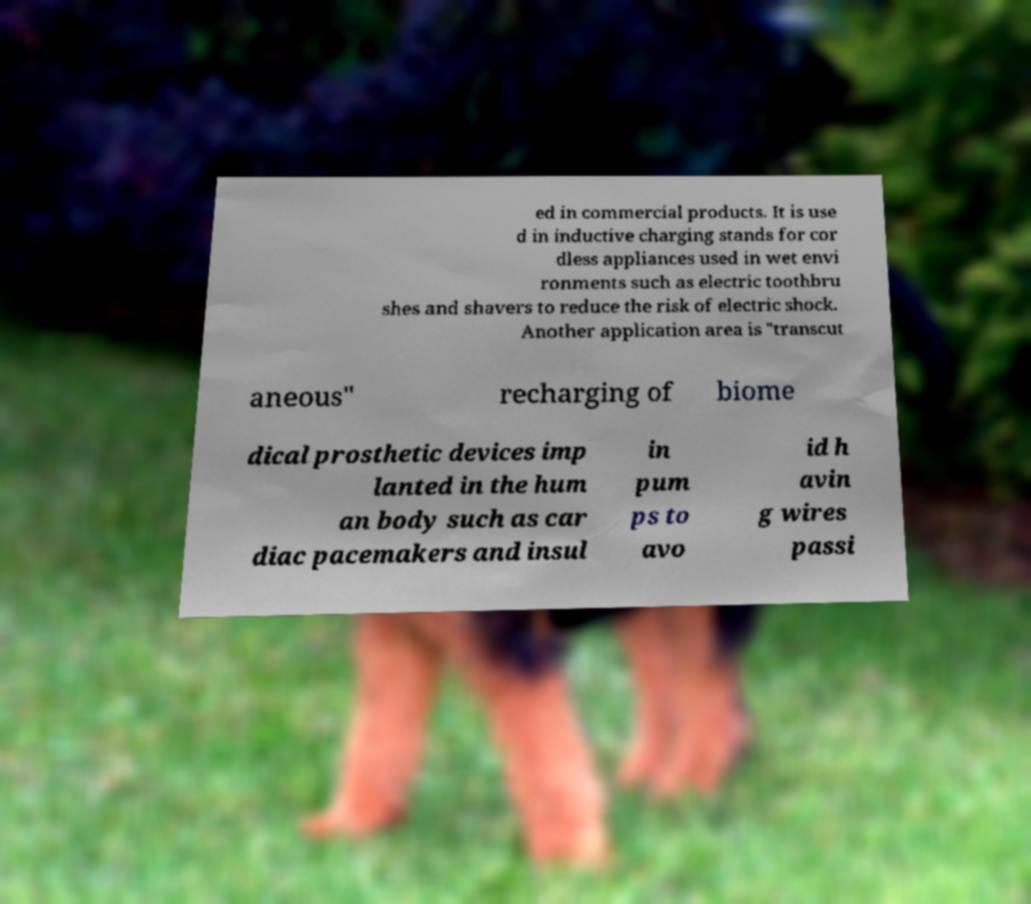For documentation purposes, I need the text within this image transcribed. Could you provide that? ed in commercial products. It is use d in inductive charging stands for cor dless appliances used in wet envi ronments such as electric toothbru shes and shavers to reduce the risk of electric shock. Another application area is "transcut aneous" recharging of biome dical prosthetic devices imp lanted in the hum an body such as car diac pacemakers and insul in pum ps to avo id h avin g wires passi 